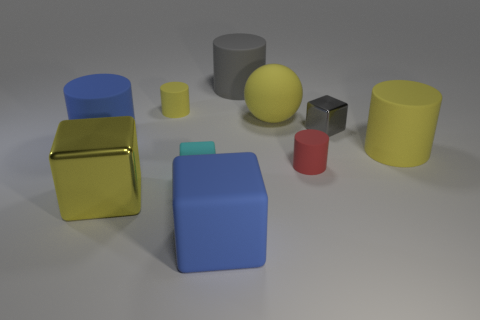Do the ball and the small rubber cylinder that is behind the large yellow cylinder have the same color?
Your response must be concise. Yes. Are there any other things that are made of the same material as the tiny yellow cylinder?
Your answer should be very brief. Yes. There is a cyan rubber thing that is in front of the small gray cube that is on the right side of the small red object; what shape is it?
Provide a succinct answer. Cube. What size is the block that is the same color as the big sphere?
Ensure brevity in your answer.  Large. Does the matte thing on the left side of the yellow metallic object have the same shape as the small gray object?
Keep it short and to the point. No. Is the number of blue cylinders that are in front of the big metal object greater than the number of big blue matte cylinders that are behind the gray rubber cylinder?
Your answer should be compact. No. There is a yellow matte cylinder on the right side of the blue rubber cube; what number of large shiny blocks are on the right side of it?
Provide a short and direct response. 0. What is the material of the small cylinder that is the same color as the big matte ball?
Offer a terse response. Rubber. What number of other things are there of the same color as the rubber sphere?
Give a very brief answer. 3. There is a tiny rubber cylinder to the left of the tiny red matte thing right of the large yellow metallic object; what color is it?
Provide a short and direct response. Yellow. 